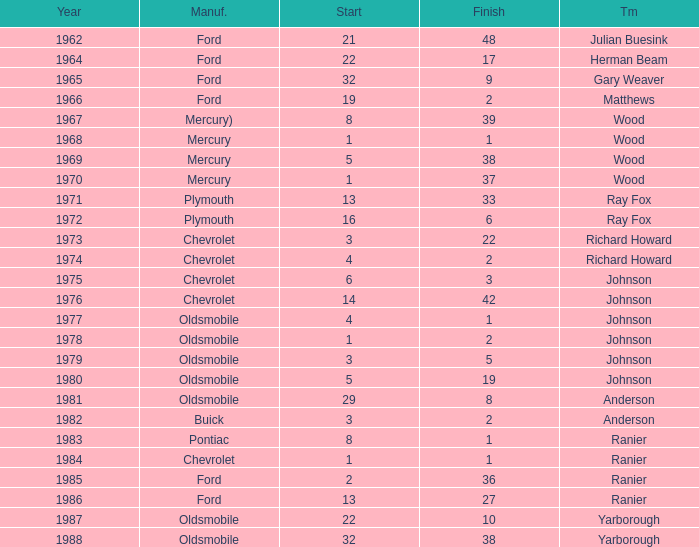What is the smallest finish time for a race where start was less than 3, buick was the manufacturer, and the race was held after 1978? None. 